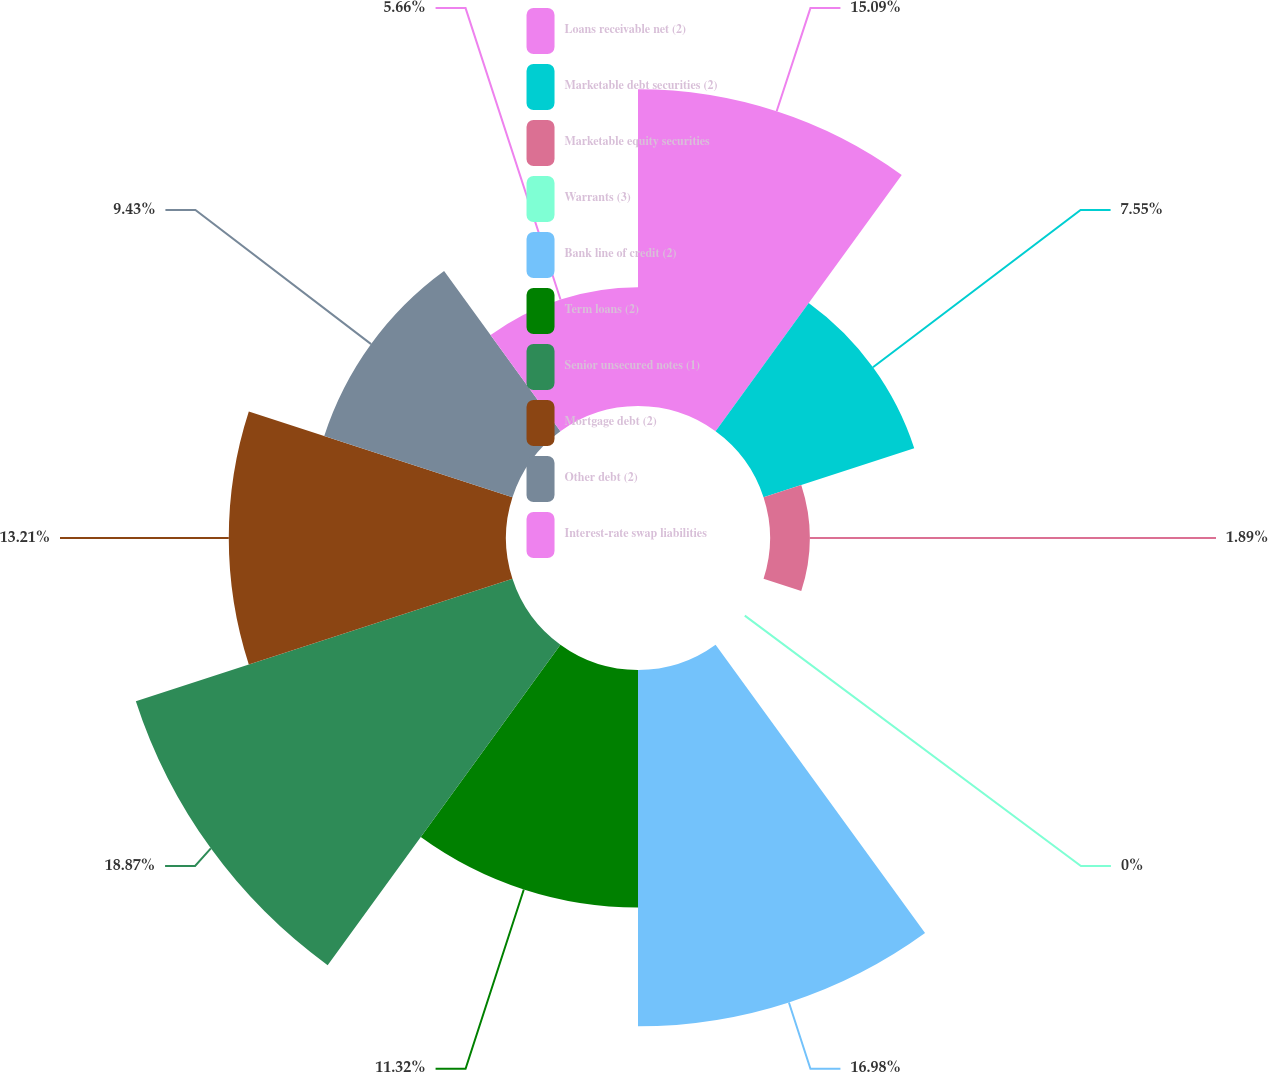Convert chart to OTSL. <chart><loc_0><loc_0><loc_500><loc_500><pie_chart><fcel>Loans receivable net (2)<fcel>Marketable debt securities (2)<fcel>Marketable equity securities<fcel>Warrants (3)<fcel>Bank line of credit (2)<fcel>Term loans (2)<fcel>Senior unsecured notes (1)<fcel>Mortgage debt (2)<fcel>Other debt (2)<fcel>Interest-rate swap liabilities<nl><fcel>15.09%<fcel>7.55%<fcel>1.89%<fcel>0.0%<fcel>16.98%<fcel>11.32%<fcel>18.87%<fcel>13.21%<fcel>9.43%<fcel>5.66%<nl></chart> 